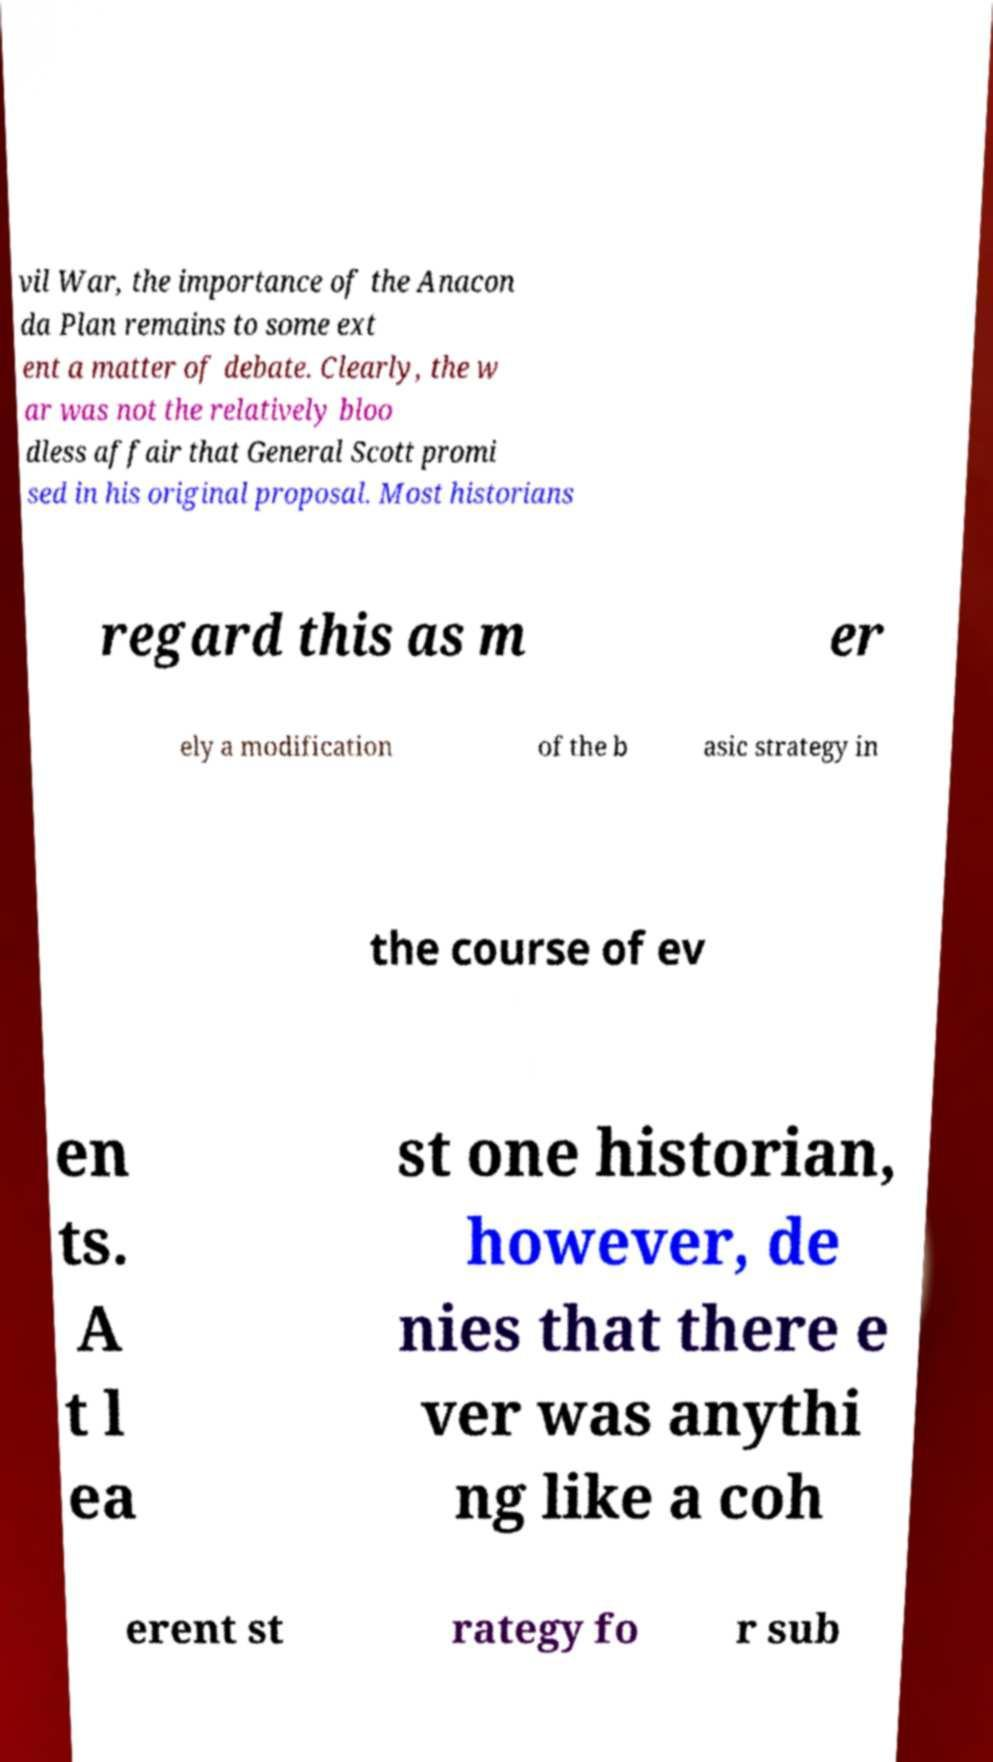Can you accurately transcribe the text from the provided image for me? vil War, the importance of the Anacon da Plan remains to some ext ent a matter of debate. Clearly, the w ar was not the relatively bloo dless affair that General Scott promi sed in his original proposal. Most historians regard this as m er ely a modification of the b asic strategy in the course of ev en ts. A t l ea st one historian, however, de nies that there e ver was anythi ng like a coh erent st rategy fo r sub 